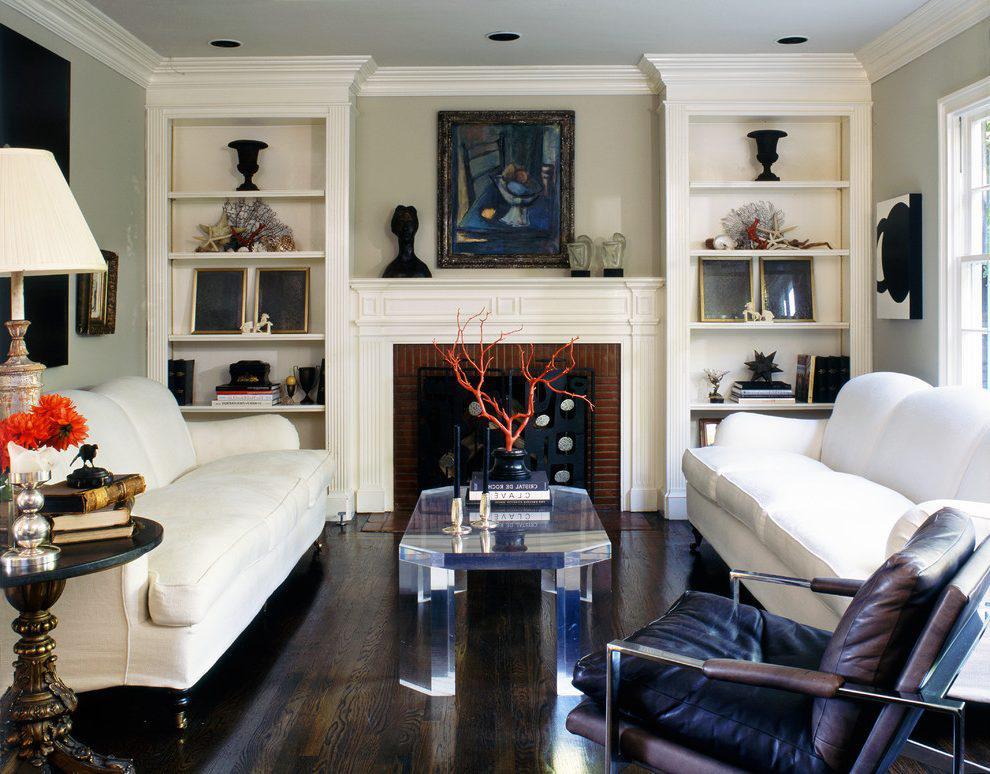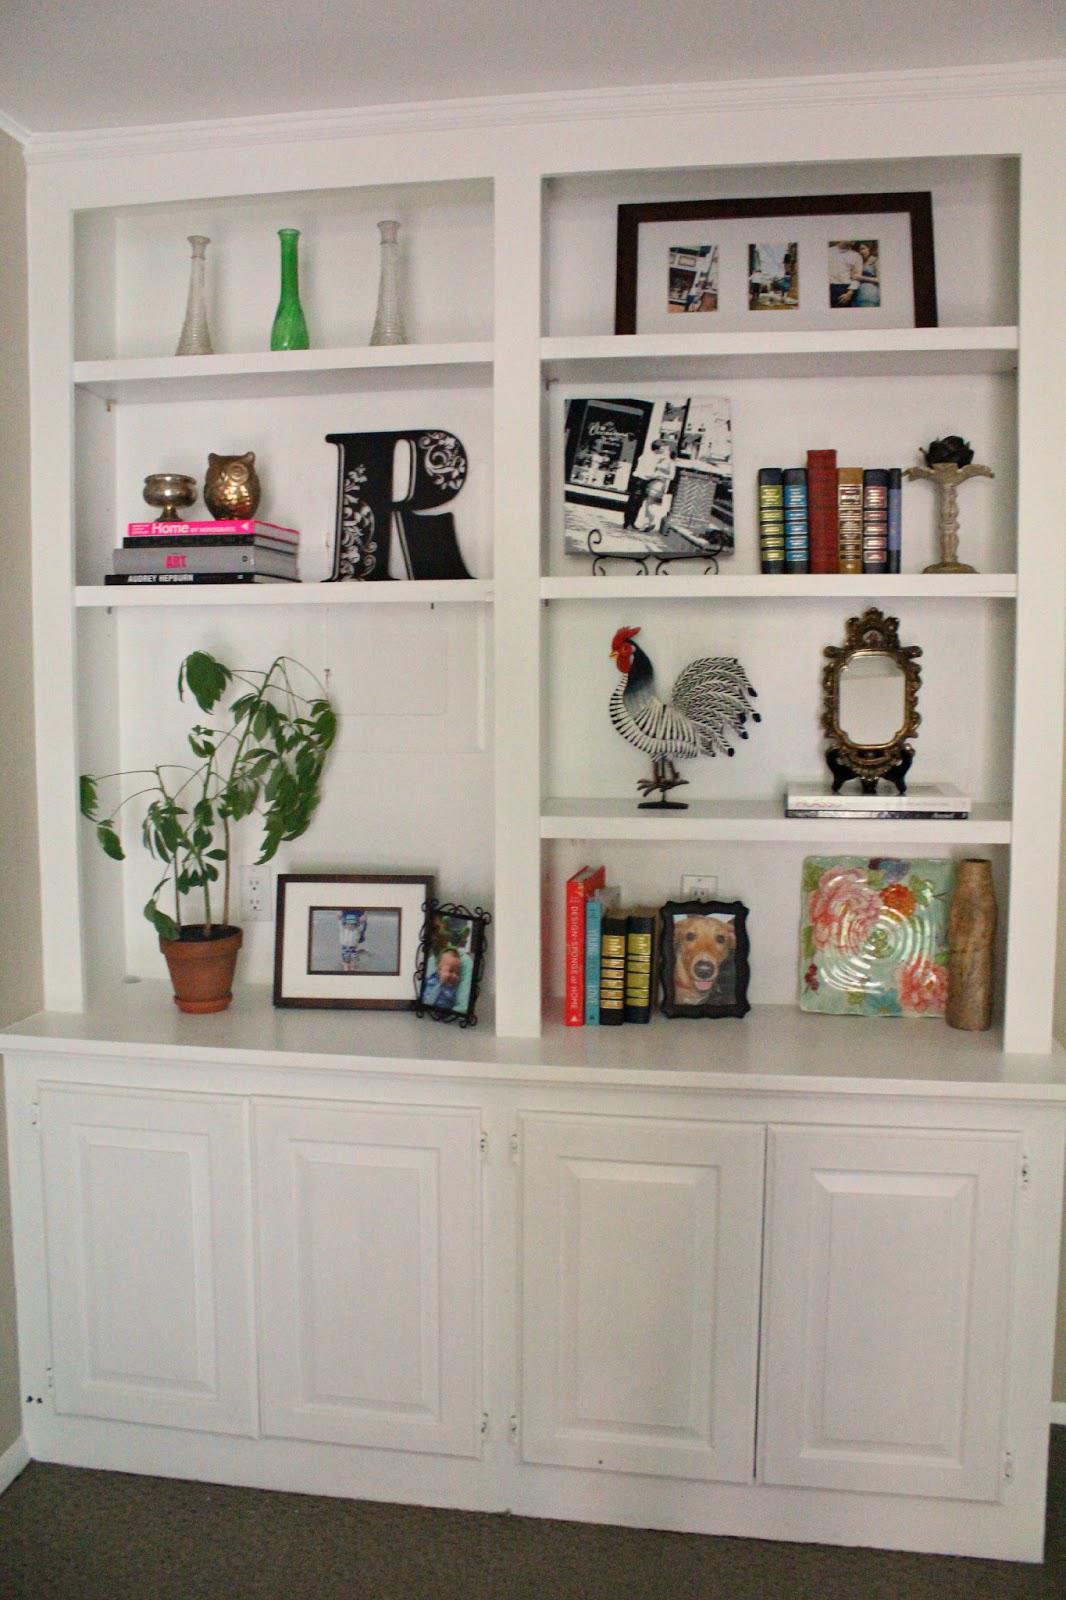The first image is the image on the left, the second image is the image on the right. Analyze the images presented: Is the assertion "In one image, floor to ceiling shelving units topped with crown molding flank a fire place and mantle." valid? Answer yes or no. Yes. 